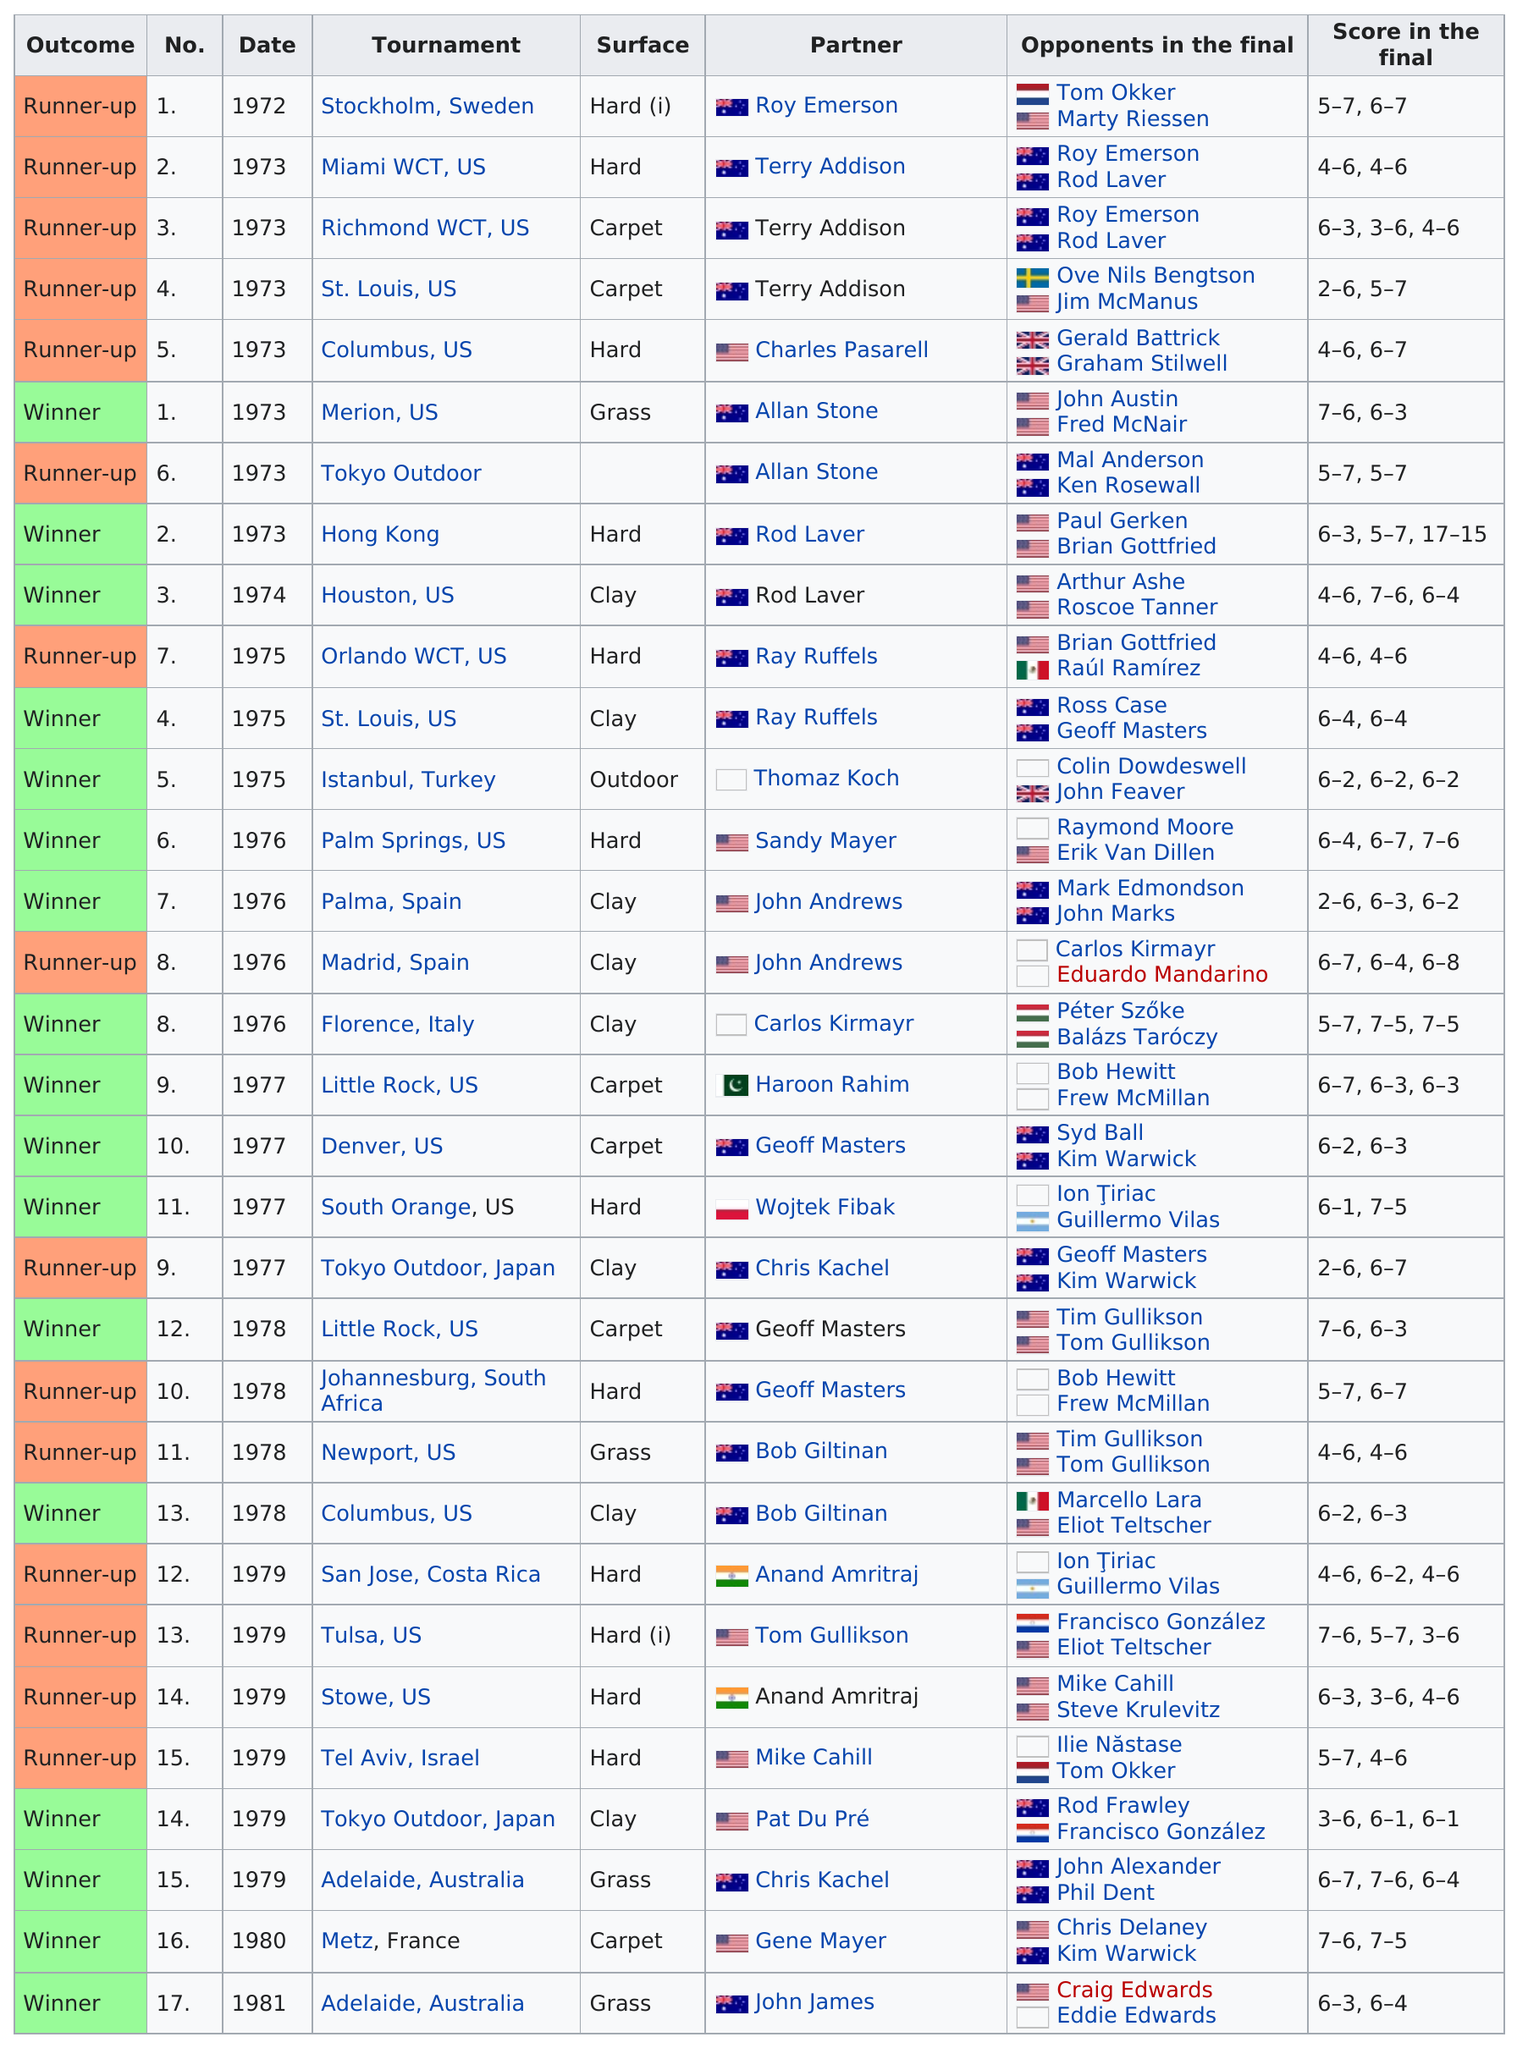Outline some significant characteristics in this image. In 1972, Dibley did not win a double final. Hard surface courts have the most champions because they provide faster and more unpredictable bounces, which can make it more challenging for players to consistently execute their shots and strategies. 